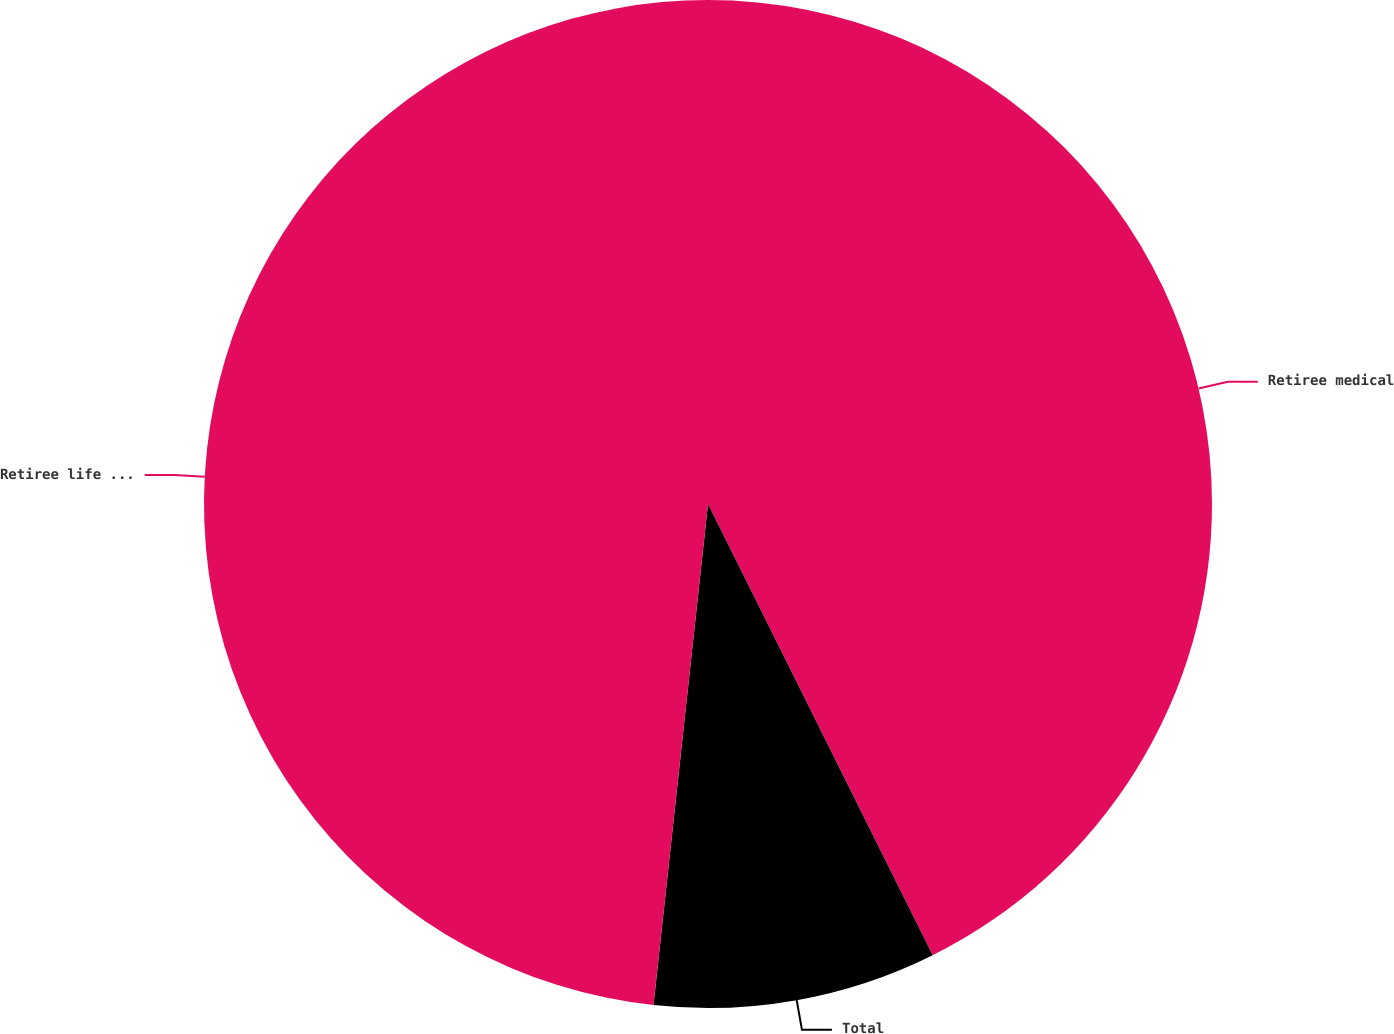Convert chart to OTSL. <chart><loc_0><loc_0><loc_500><loc_500><pie_chart><fcel>Retiree medical<fcel>Total<fcel>Retiree life  insurance<nl><fcel>42.65%<fcel>9.08%<fcel>48.28%<nl></chart> 